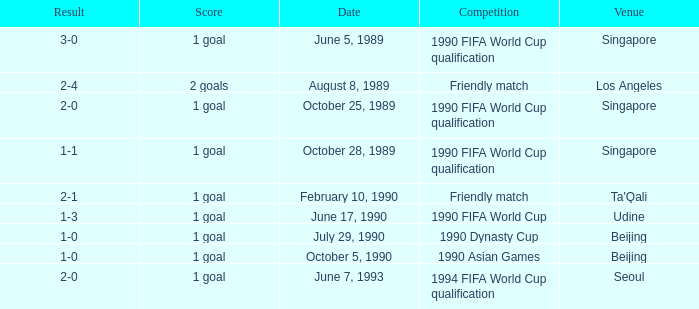What is the competition at the ta'qali venue? Friendly match. 